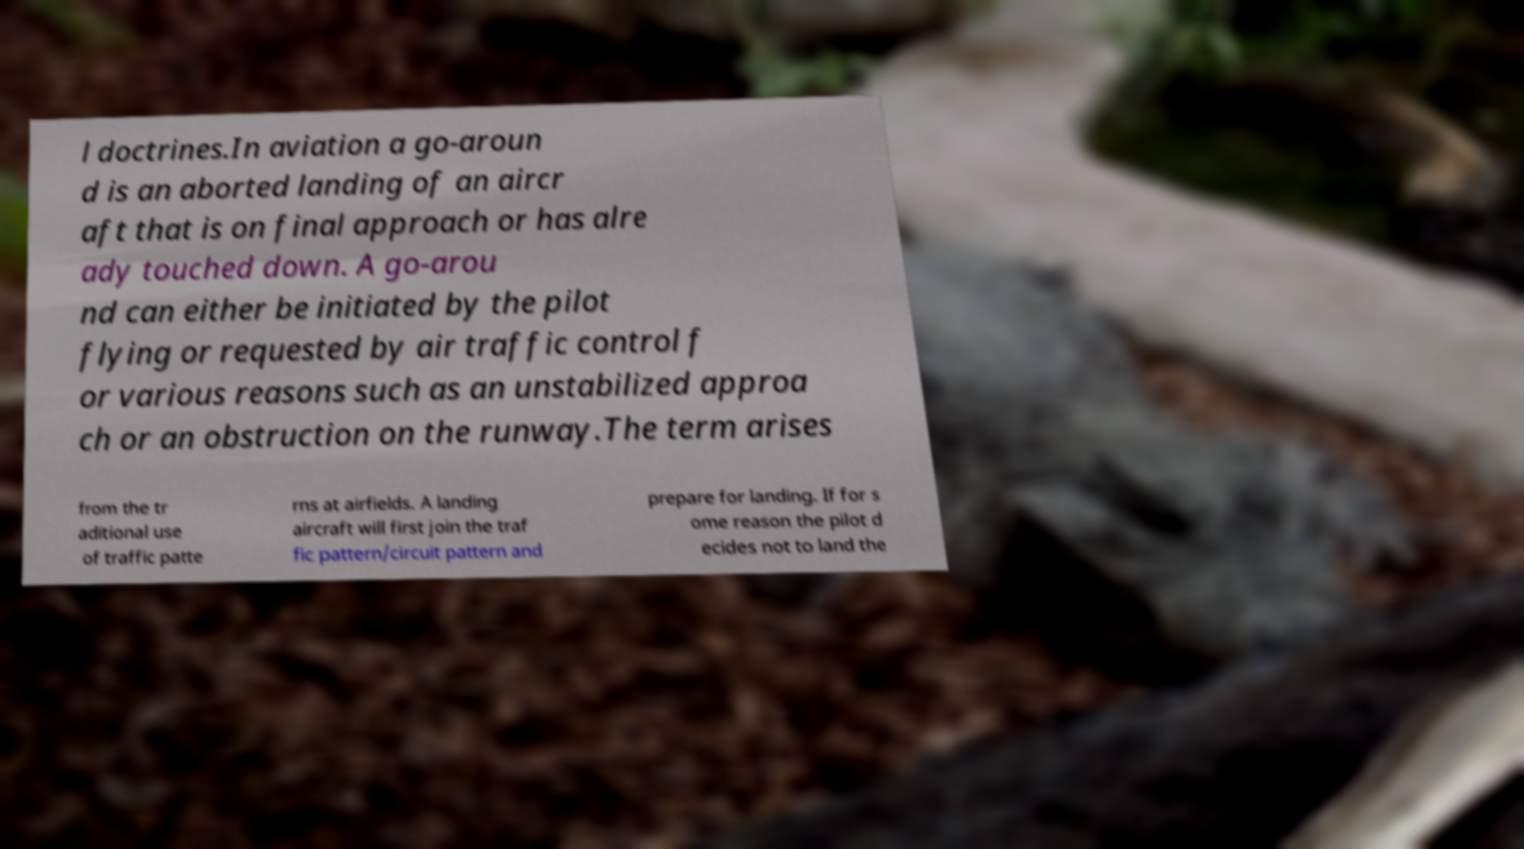Can you accurately transcribe the text from the provided image for me? l doctrines.In aviation a go-aroun d is an aborted landing of an aircr aft that is on final approach or has alre ady touched down. A go-arou nd can either be initiated by the pilot flying or requested by air traffic control f or various reasons such as an unstabilized approa ch or an obstruction on the runway.The term arises from the tr aditional use of traffic patte rns at airfields. A landing aircraft will first join the traf fic pattern/circuit pattern and prepare for landing. If for s ome reason the pilot d ecides not to land the 